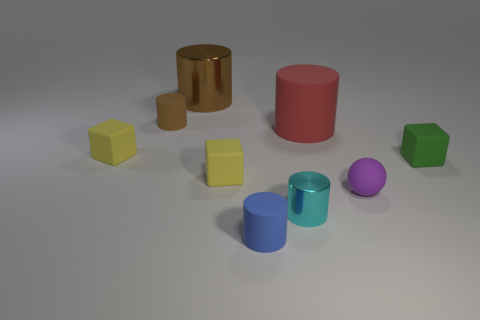Subtract 3 cylinders. How many cylinders are left? 2 Subtract all blue cylinders. How many cylinders are left? 4 Subtract all shiny cylinders. How many cylinders are left? 3 Subtract all yellow cylinders. Subtract all yellow cubes. How many cylinders are left? 5 Add 1 tiny brown matte objects. How many objects exist? 10 Subtract all spheres. How many objects are left? 8 Subtract 1 green blocks. How many objects are left? 8 Subtract all red rubber cylinders. Subtract all large brown cubes. How many objects are left? 8 Add 9 blue matte things. How many blue matte things are left? 10 Add 3 tiny blue rubber cylinders. How many tiny blue rubber cylinders exist? 4 